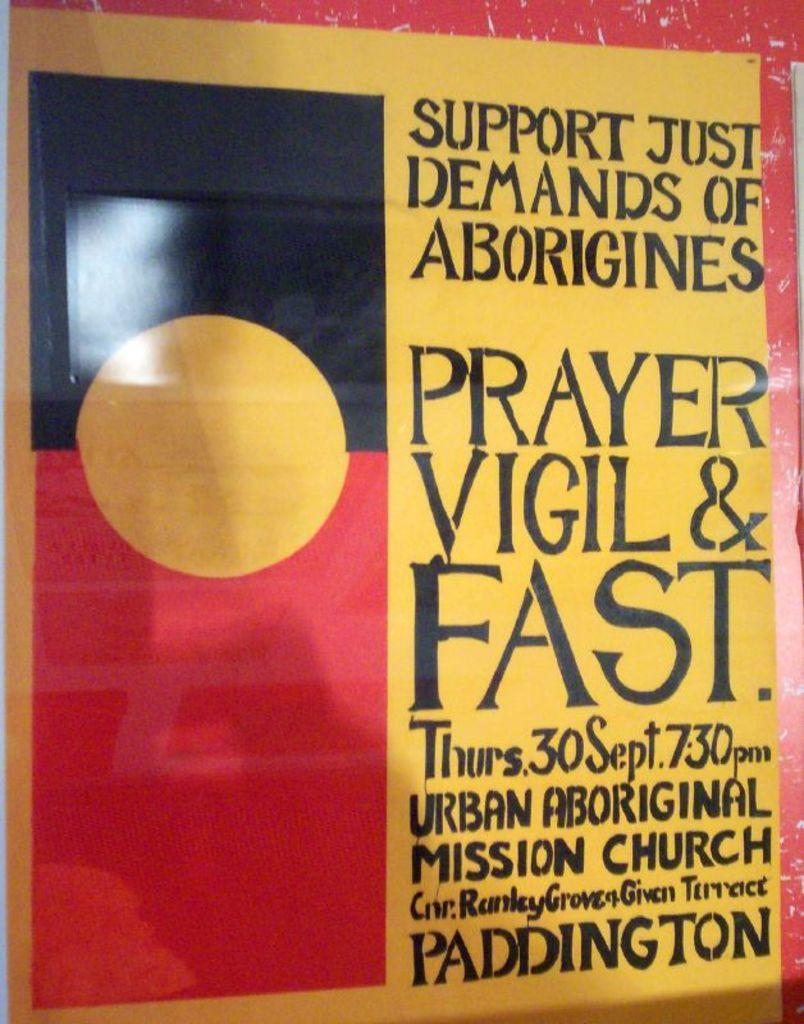<image>
Write a terse but informative summary of the picture. A poster that is written with marker and says Support Just Demands of Aborigines. 